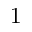Convert formula to latex. <formula><loc_0><loc_0><loc_500><loc_500>1</formula> 